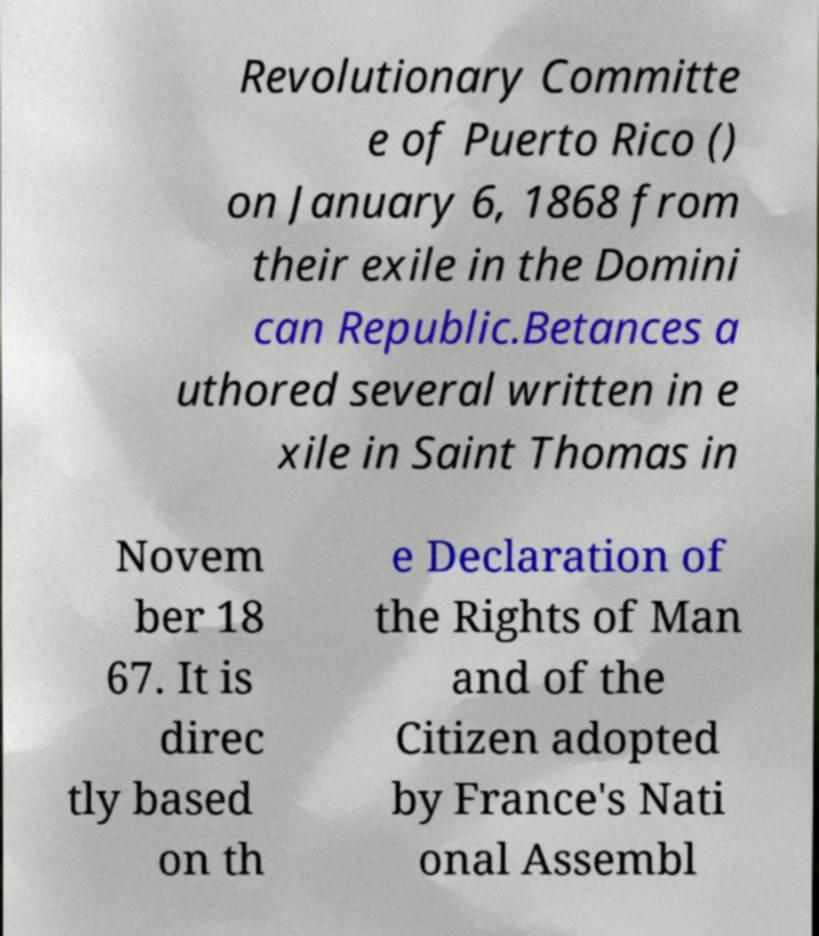Please read and relay the text visible in this image. What does it say? Revolutionary Committe e of Puerto Rico () on January 6, 1868 from their exile in the Domini can Republic.Betances a uthored several written in e xile in Saint Thomas in Novem ber 18 67. It is direc tly based on th e Declaration of the Rights of Man and of the Citizen adopted by France's Nati onal Assembl 